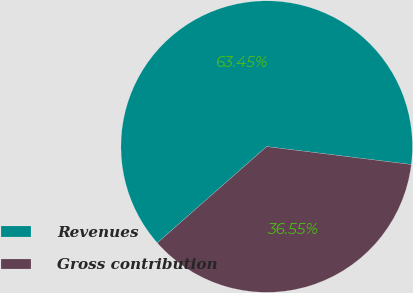<chart> <loc_0><loc_0><loc_500><loc_500><pie_chart><fcel>Revenues<fcel>Gross contribution<nl><fcel>63.45%<fcel>36.55%<nl></chart> 